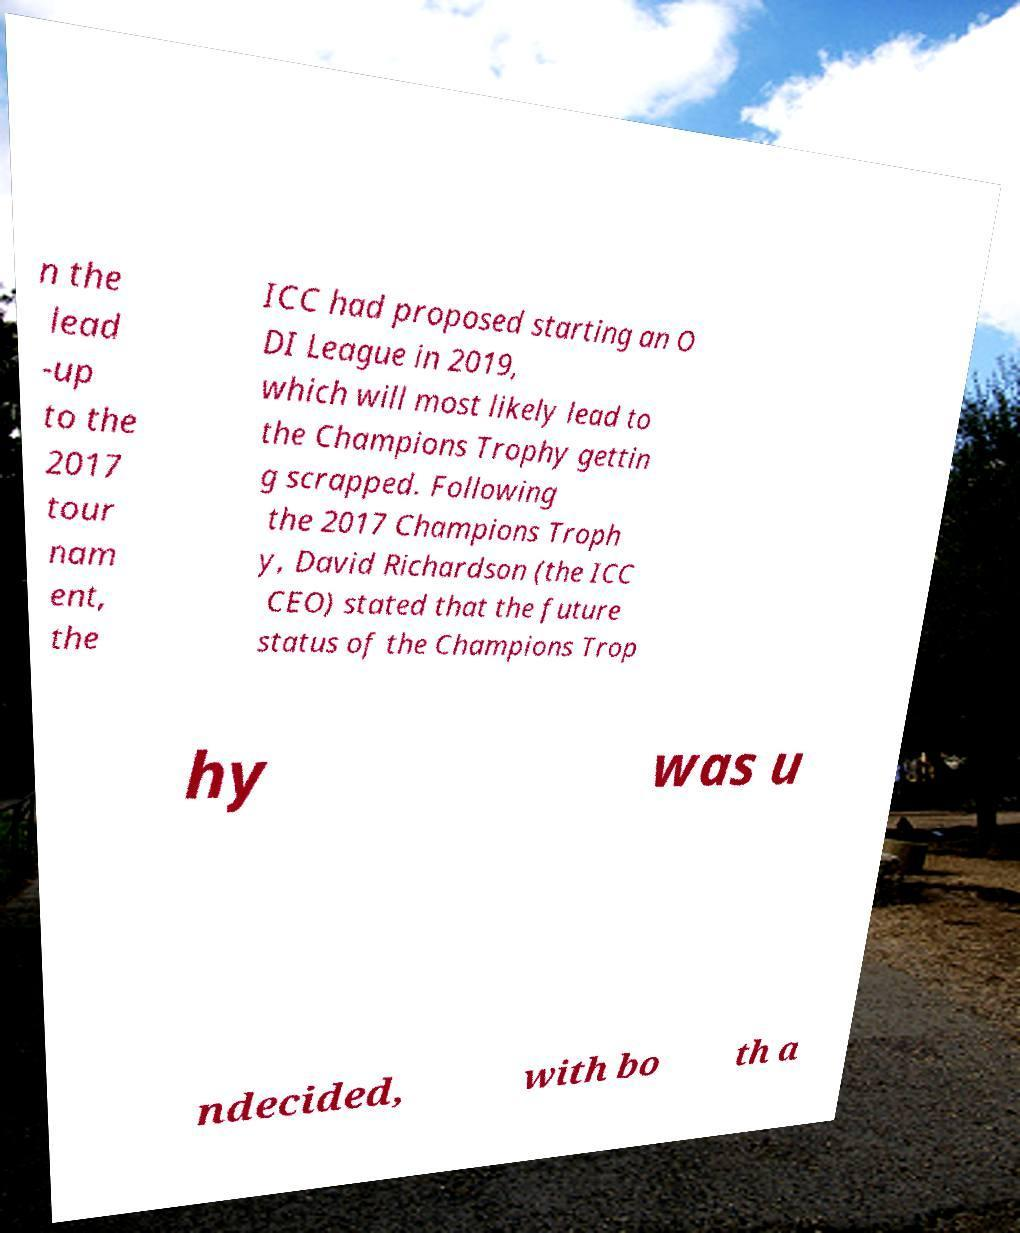Could you extract and type out the text from this image? n the lead -up to the 2017 tour nam ent, the ICC had proposed starting an O DI League in 2019, which will most likely lead to the Champions Trophy gettin g scrapped. Following the 2017 Champions Troph y, David Richardson (the ICC CEO) stated that the future status of the Champions Trop hy was u ndecided, with bo th a 